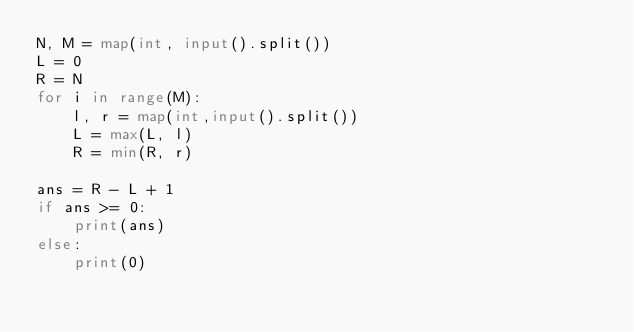<code> <loc_0><loc_0><loc_500><loc_500><_Python_>N, M = map(int, input().split())
L = 0
R = N
for i in range(M):
    l, r = map(int,input().split())
    L = max(L, l)
    R = min(R, r)

ans = R - L + 1
if ans >= 0:
    print(ans)
else:
    print(0)</code> 